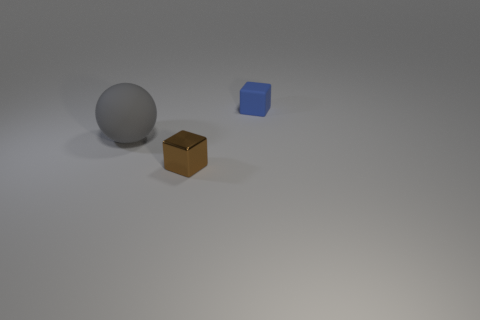Add 1 small cyan things. How many objects exist? 4 Subtract all blocks. How many objects are left? 1 Subtract all blue metallic cylinders. Subtract all big gray balls. How many objects are left? 2 Add 2 rubber spheres. How many rubber spheres are left? 3 Add 1 gray objects. How many gray objects exist? 2 Subtract 0 brown cylinders. How many objects are left? 3 